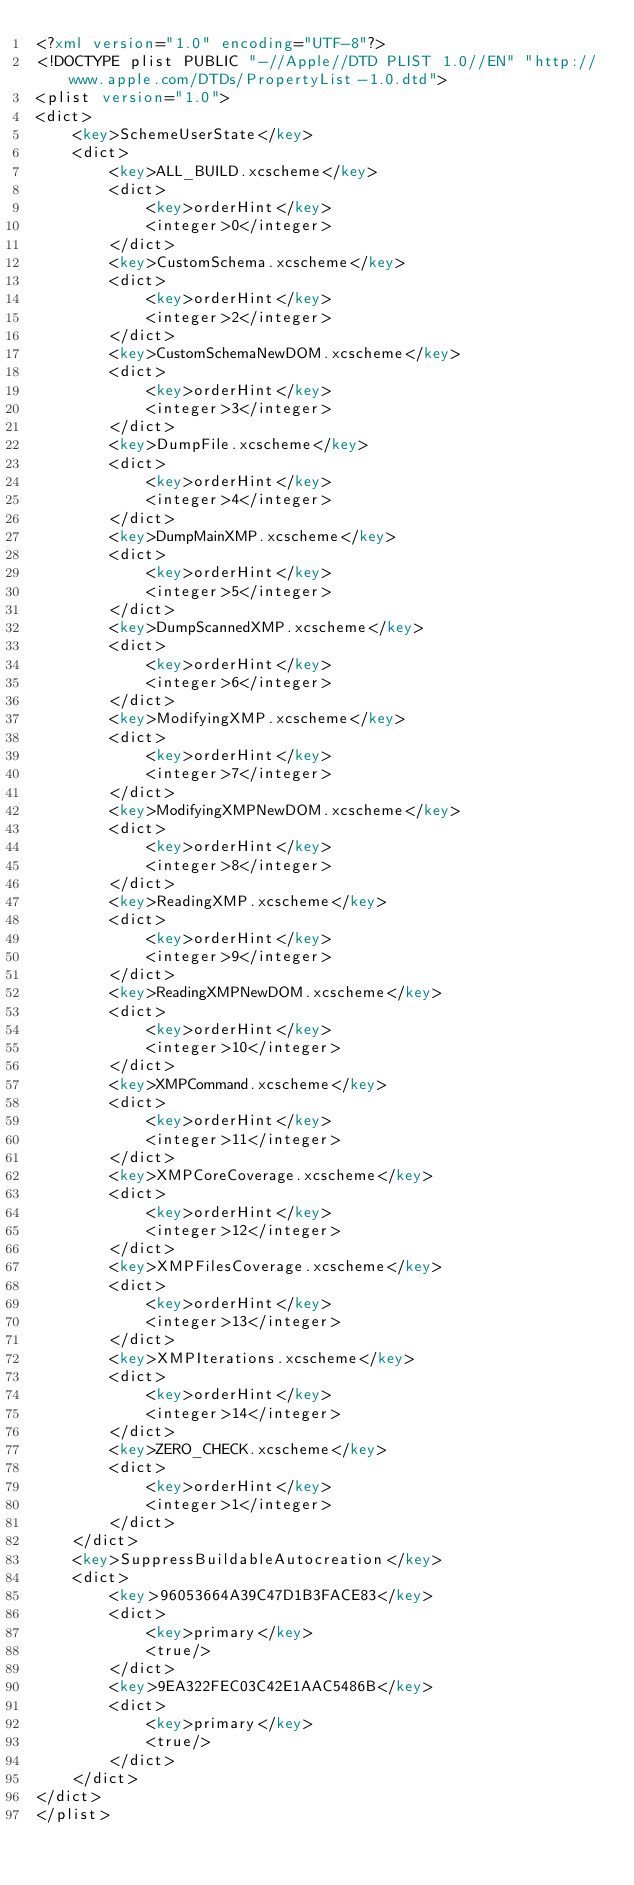Convert code to text. <code><loc_0><loc_0><loc_500><loc_500><_XML_><?xml version="1.0" encoding="UTF-8"?>
<!DOCTYPE plist PUBLIC "-//Apple//DTD PLIST 1.0//EN" "http://www.apple.com/DTDs/PropertyList-1.0.dtd">
<plist version="1.0">
<dict>
	<key>SchemeUserState</key>
	<dict>
		<key>ALL_BUILD.xcscheme</key>
		<dict>
			<key>orderHint</key>
			<integer>0</integer>
		</dict>
		<key>CustomSchema.xcscheme</key>
		<dict>
			<key>orderHint</key>
			<integer>2</integer>
		</dict>
		<key>CustomSchemaNewDOM.xcscheme</key>
		<dict>
			<key>orderHint</key>
			<integer>3</integer>
		</dict>
		<key>DumpFile.xcscheme</key>
		<dict>
			<key>orderHint</key>
			<integer>4</integer>
		</dict>
		<key>DumpMainXMP.xcscheme</key>
		<dict>
			<key>orderHint</key>
			<integer>5</integer>
		</dict>
		<key>DumpScannedXMP.xcscheme</key>
		<dict>
			<key>orderHint</key>
			<integer>6</integer>
		</dict>
		<key>ModifyingXMP.xcscheme</key>
		<dict>
			<key>orderHint</key>
			<integer>7</integer>
		</dict>
		<key>ModifyingXMPNewDOM.xcscheme</key>
		<dict>
			<key>orderHint</key>
			<integer>8</integer>
		</dict>
		<key>ReadingXMP.xcscheme</key>
		<dict>
			<key>orderHint</key>
			<integer>9</integer>
		</dict>
		<key>ReadingXMPNewDOM.xcscheme</key>
		<dict>
			<key>orderHint</key>
			<integer>10</integer>
		</dict>
		<key>XMPCommand.xcscheme</key>
		<dict>
			<key>orderHint</key>
			<integer>11</integer>
		</dict>
		<key>XMPCoreCoverage.xcscheme</key>
		<dict>
			<key>orderHint</key>
			<integer>12</integer>
		</dict>
		<key>XMPFilesCoverage.xcscheme</key>
		<dict>
			<key>orderHint</key>
			<integer>13</integer>
		</dict>
		<key>XMPIterations.xcscheme</key>
		<dict>
			<key>orderHint</key>
			<integer>14</integer>
		</dict>
		<key>ZERO_CHECK.xcscheme</key>
		<dict>
			<key>orderHint</key>
			<integer>1</integer>
		</dict>
	</dict>
	<key>SuppressBuildableAutocreation</key>
	<dict>
		<key>96053664A39C47D1B3FACE83</key>
		<dict>
			<key>primary</key>
			<true/>
		</dict>
		<key>9EA322FEC03C42E1AAC5486B</key>
		<dict>
			<key>primary</key>
			<true/>
		</dict>
	</dict>
</dict>
</plist>
</code> 